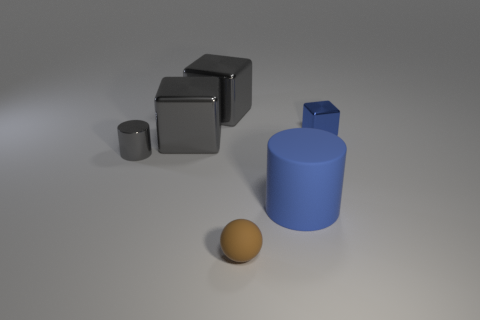Add 4 big spheres. How many objects exist? 10 Subtract all cylinders. How many objects are left? 4 Subtract 0 gray balls. How many objects are left? 6 Subtract all small red things. Subtract all large blue matte cylinders. How many objects are left? 5 Add 5 blue shiny cubes. How many blue shiny cubes are left? 6 Add 6 brown cylinders. How many brown cylinders exist? 6 